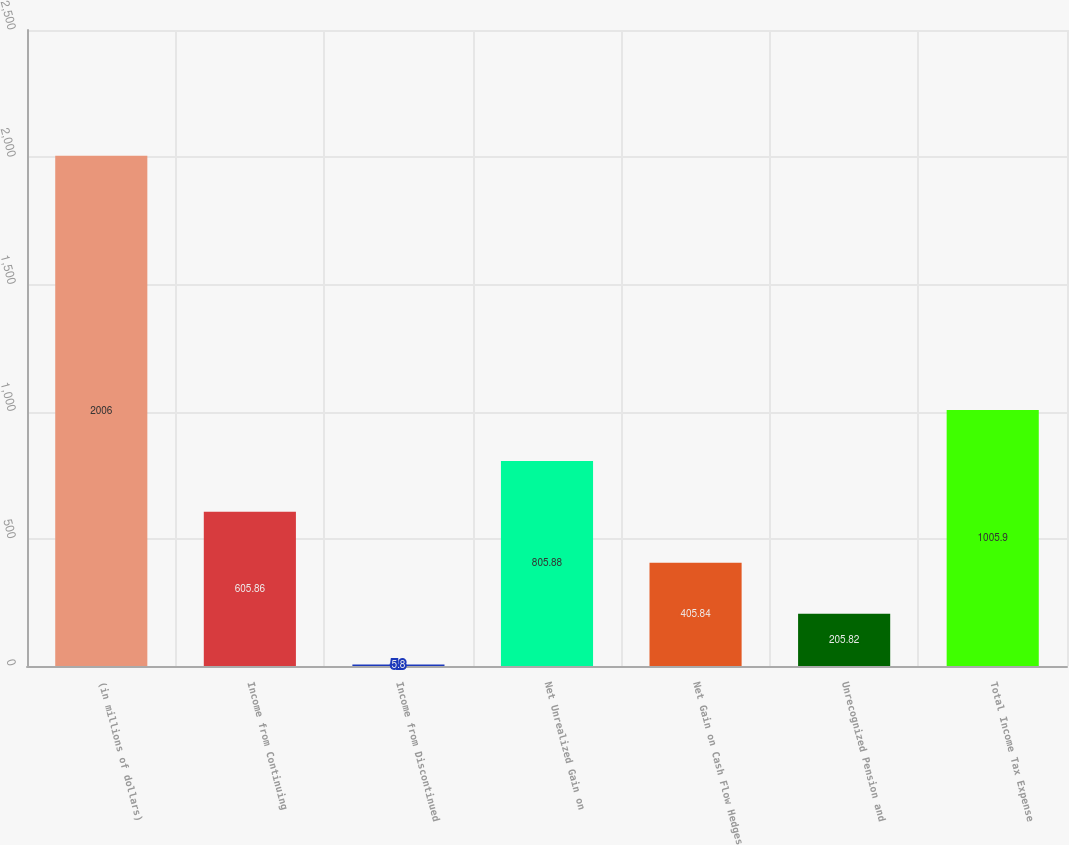Convert chart. <chart><loc_0><loc_0><loc_500><loc_500><bar_chart><fcel>(in millions of dollars)<fcel>Income from Continuing<fcel>Income from Discontinued<fcel>Net Unrealized Gain on<fcel>Net Gain on Cash Flow Hedges<fcel>Unrecognized Pension and<fcel>Total Income Tax Expense<nl><fcel>2006<fcel>605.86<fcel>5.8<fcel>805.88<fcel>405.84<fcel>205.82<fcel>1005.9<nl></chart> 